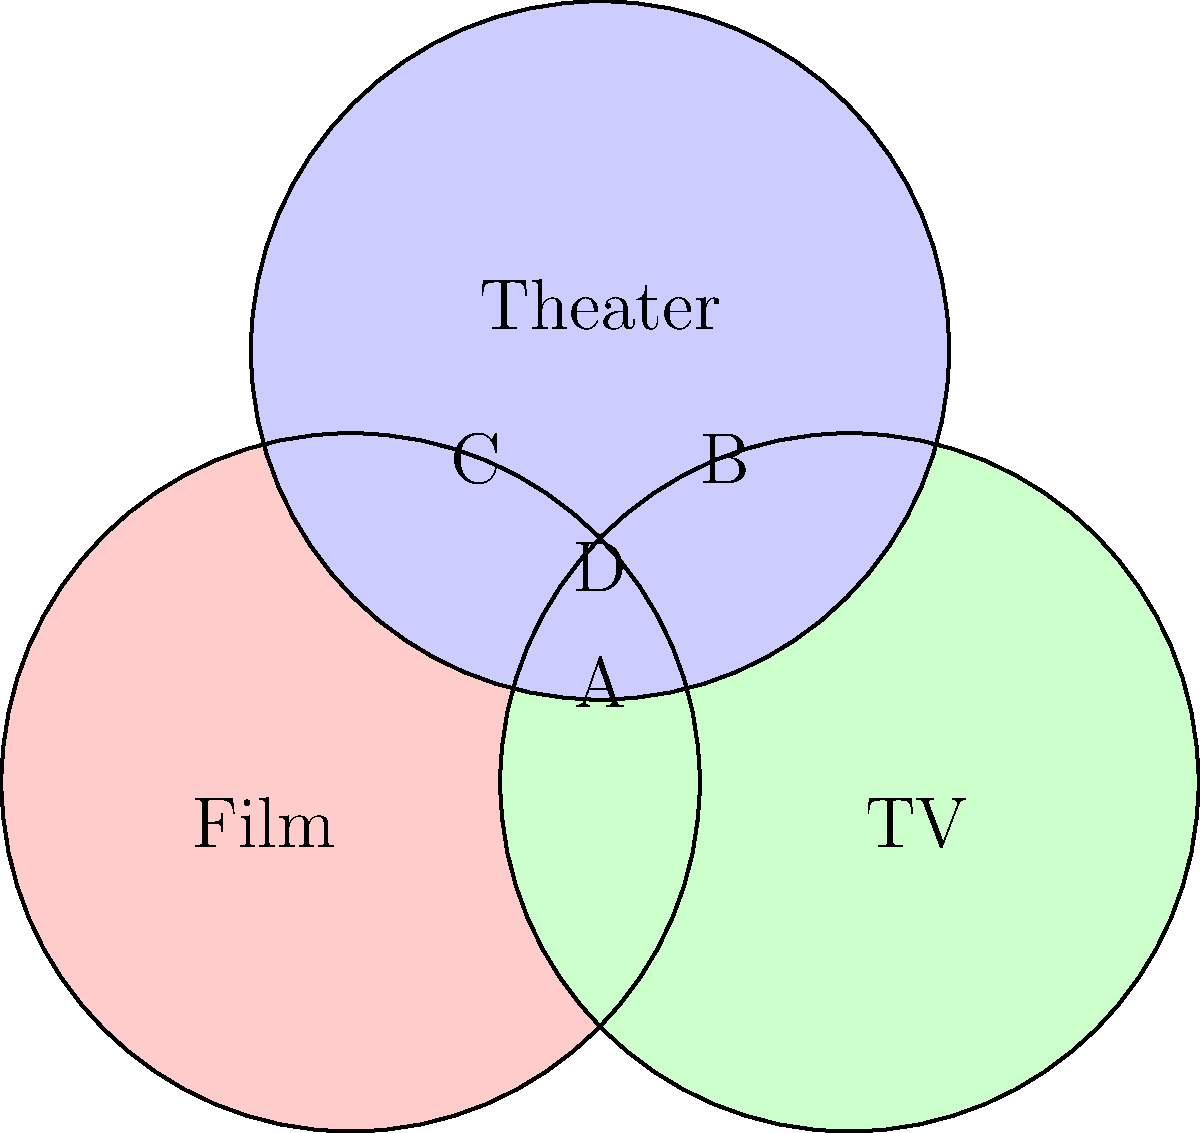In the Venn diagram above, the circles represent different sectors of the entertainment industry: Film, TV, and Theater. Areas A, B, C, and D represent talent with experience in multiple sectors. As a talent agent, you're looking for an actor with experience in all three sectors. Which area in the diagram represents this type of versatile talent? To answer this question, we need to understand what each area in the Venn diagram represents:

1. Area A: Represents talent with experience in both Film and TV, but not Theater.
2. Area B: Represents talent with experience in both TV and Theater, but not Film.
3. Area C: Represents talent with experience in both Film and Theater, but not TV.
4. Area D: Represents the intersection of all three circles, meaning talent with experience in Film, TV, and Theater.

As a talent agent looking for an actor with experience in all three sectors (Film, TV, and Theater), we need to find the area where all three circles overlap. This is represented by area D in the center of the diagram.

Area D is the only region that is included in all three circles simultaneously, indicating experience in all three entertainment sectors.
Answer: D 